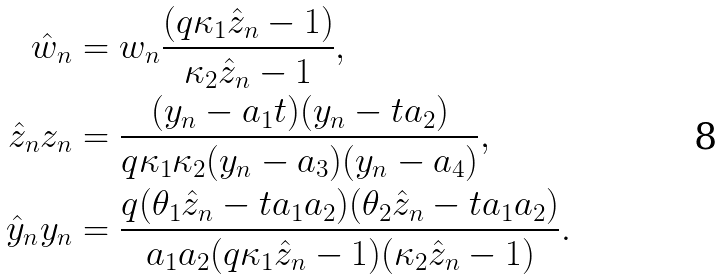<formula> <loc_0><loc_0><loc_500><loc_500>\hat { w } _ { n } & = w _ { n } \frac { ( q \kappa _ { 1 } \hat { z } _ { n } - 1 ) } { \kappa _ { 2 } \hat { z } _ { n } - 1 } , \\ \hat { z } _ { n } z _ { n } & = \frac { ( y _ { n } - a _ { 1 } t ) ( y _ { n } - t a _ { 2 } ) } { q \kappa _ { 1 } \kappa _ { 2 } ( y _ { n } - a _ { 3 } ) ( y _ { n } - a _ { 4 } ) } , \\ \hat { y } _ { n } y _ { n } & = \frac { q ( \theta _ { 1 } \hat { z } _ { n } - t a _ { 1 } a _ { 2 } ) ( \theta _ { 2 } \hat { z } _ { n } - t a _ { 1 } a _ { 2 } ) } { a _ { 1 } a _ { 2 } ( q \kappa _ { 1 } \hat { z } _ { n } - 1 ) ( \kappa _ { 2 } \hat { z } _ { n } - 1 ) } .</formula> 